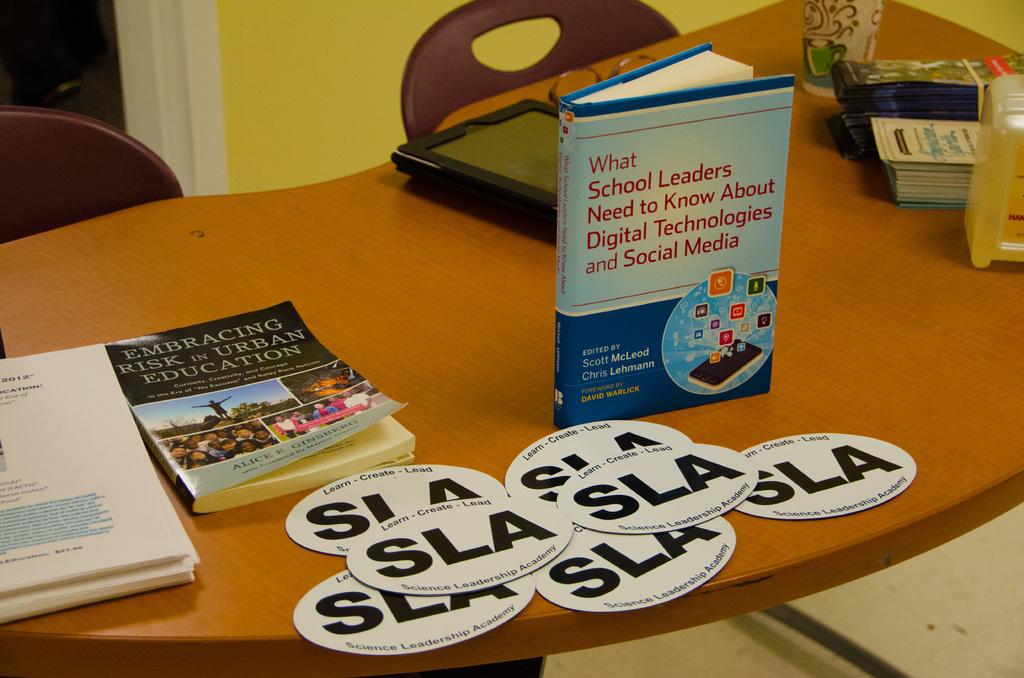What is the motto on the stickers?
Keep it short and to the point. Sla. What is the title of the book standing up?
Provide a short and direct response. What school leaders need to know about digital technologies and social media. 